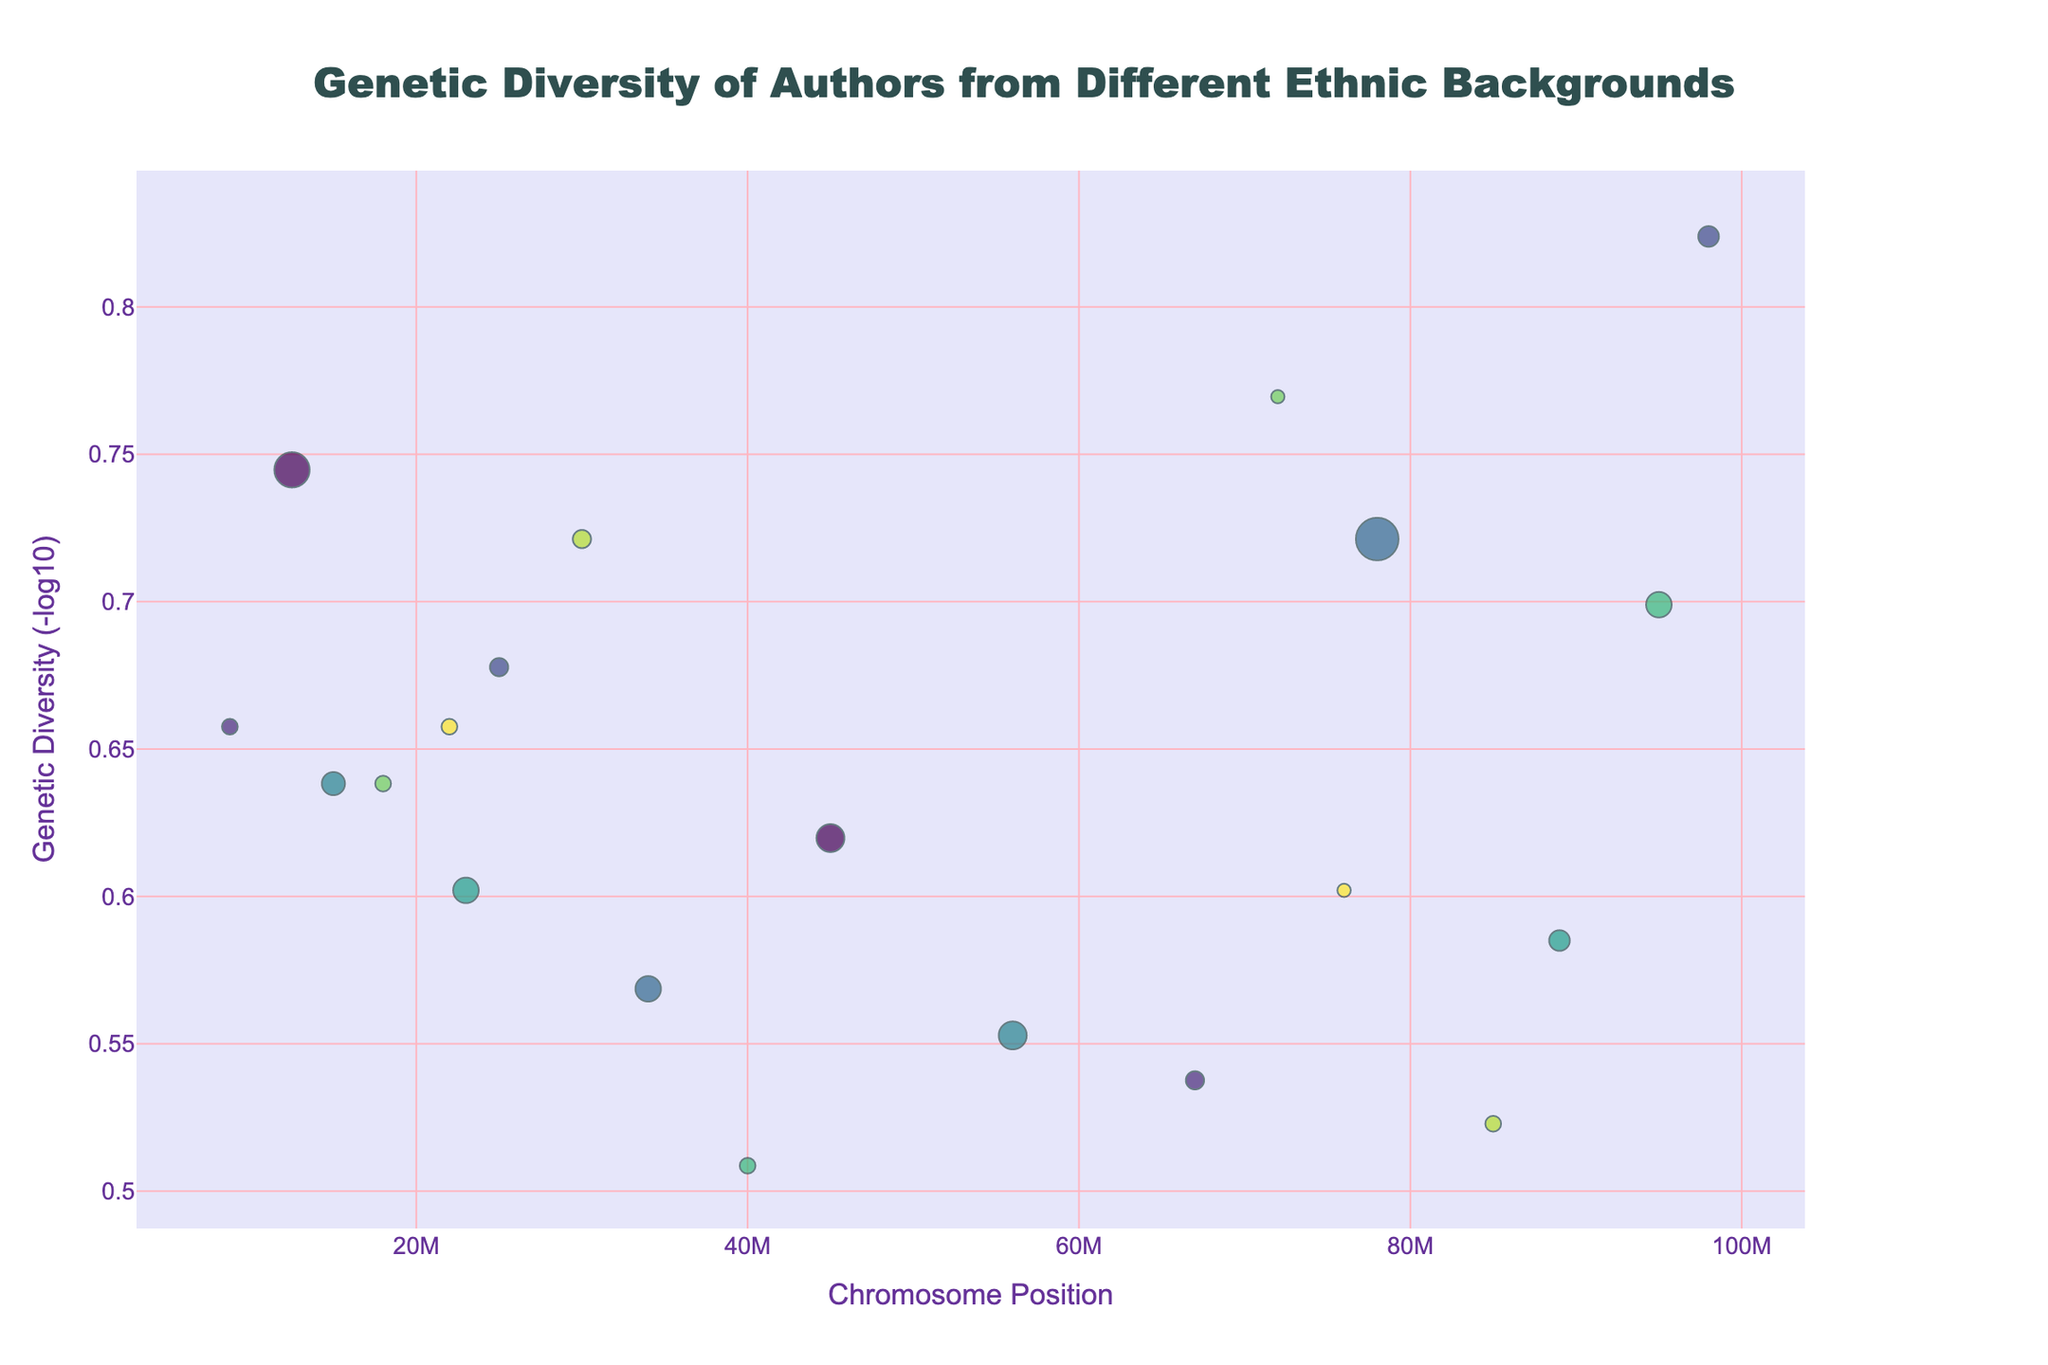What's the title of the plot? The title of the plot is located at the top center of the figure.
Answer: Genetic Diversity of Authors from Different Ethnic Backgrounds How are the colors used in the plot related to the data? The color of each marker represents the chromosome number corresponding to the author's genetic diversity data.
Answer: By Chromosome Number What is the range of Genetic Diversity values displayed? You can determine this by looking at the y-axis values spanning from the lowest to the highest markers.
Answer: Approximately 0.15 to 0.70 Which author has the highest Genetic Diversity value? The highest markers on the y-axis indicate the authors with the highest values. Chimamanda Ngozi Adichie, Arundhati Roy, and Toni Morrison have the highest Genetic Diversity values.
Answer: Chimamanda Ngozi Adichie Who is the author with the fewest novels published with a high Genetic Diversity? Looking at the markers with the largest size, Arundhati Roy stands out among the markers with high Genetic Diversity values. She has published fewer novels compared to Toni Morrison and Chimamanda Ngozi Adichie.
Answer: Arundhati Roy Which chromosome has the most authors represented on it? By counting the number of markers on each chromosome, Chromosome 5 has the most markers.
Answer: Chromosome 5 Is there a visible pattern of Genetic Diversity across different chromosomes? The markers for Genetic Diversity are scattered across different chromosome positions without a clear pattern, showing diverse values in Genetic Diversity across chromosomes.
Answer: No clear pattern Compare the Genetic Diversity of Toni Morrison and Amy Tan. Toni Morrison has a higher y-axis value (higher Genetic Diversity) than Amy Tan.
Answer: Toni Morrison has higher Genetic Diversity Which author on Chromosome 2 has the highest Genetic Diversity value? By identifying data points on Chromosome 2, Junot Díaz has the highest Genetic Diversity value on this chromosome.
Answer: Junot Díaz 